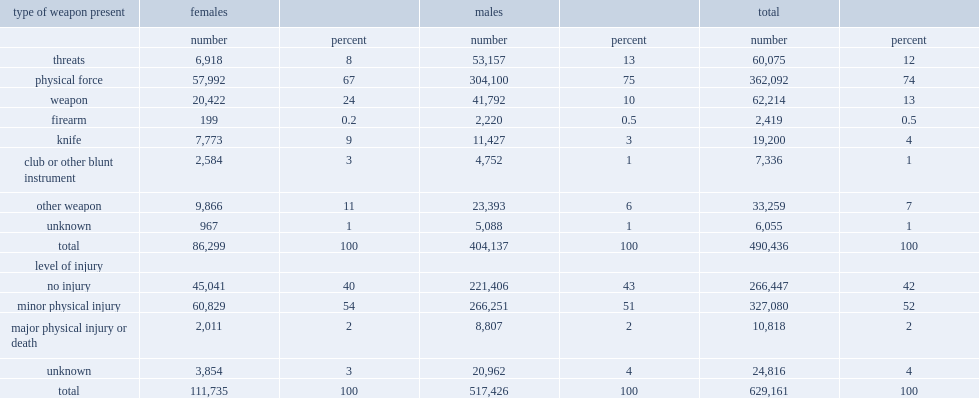Could you parse the entire table? {'header': ['type of weapon present', 'females', '', 'males', '', 'total', ''], 'rows': [['', 'number', 'percent', 'number', 'percent', 'number', 'percent'], ['threats', '6,918', '8', '53,157', '13', '60,075', '12'], ['physical force', '57,992', '67', '304,100', '75', '362,092', '74'], ['weapon', '20,422', '24', '41,792', '10', '62,214', '13'], ['firearm', '199', '0.2', '2,220', '0.5', '2,419', '0.5'], ['knife', '7,773', '9', '11,427', '3', '19,200', '4'], ['club or other blunt instrument', '2,584', '3', '4,752', '1', '7,336', '1'], ['other weapon', '9,866', '11', '23,393', '6', '33,259', '7'], ['unknown', '967', '1', '5,088', '1', '6,055', '1'], ['total', '86,299', '100', '404,137', '100', '490,436', '100'], ['level of injury', '', '', '', '', '', ''], ['no injury', '45,041', '40', '221,406', '43', '266,447', '42'], ['minor physical injury', '60,829', '54', '266,251', '51', '327,080', '52'], ['major physical injury or death', '2,011', '2', '8,807', '2', '10,818', '2'], ['unknown', '3,854', '3', '20,962', '4', '24,816', '4'], ['total', '111,735', '100', '517,426', '100', '629,161', '100']]} When it comes to ipv, which group of people were most likely to present weapon in incidents involving in opposite-sex relationships? males or females? Females. What percentage of victms suffering physical injuries is associated with incidents involving opposite-sex ipv partners? 54. How many percent of incidents of police-reported opposite-sex intimate partner violence in canada is associated with incidents led to major physical injuries or death? 2.0. 